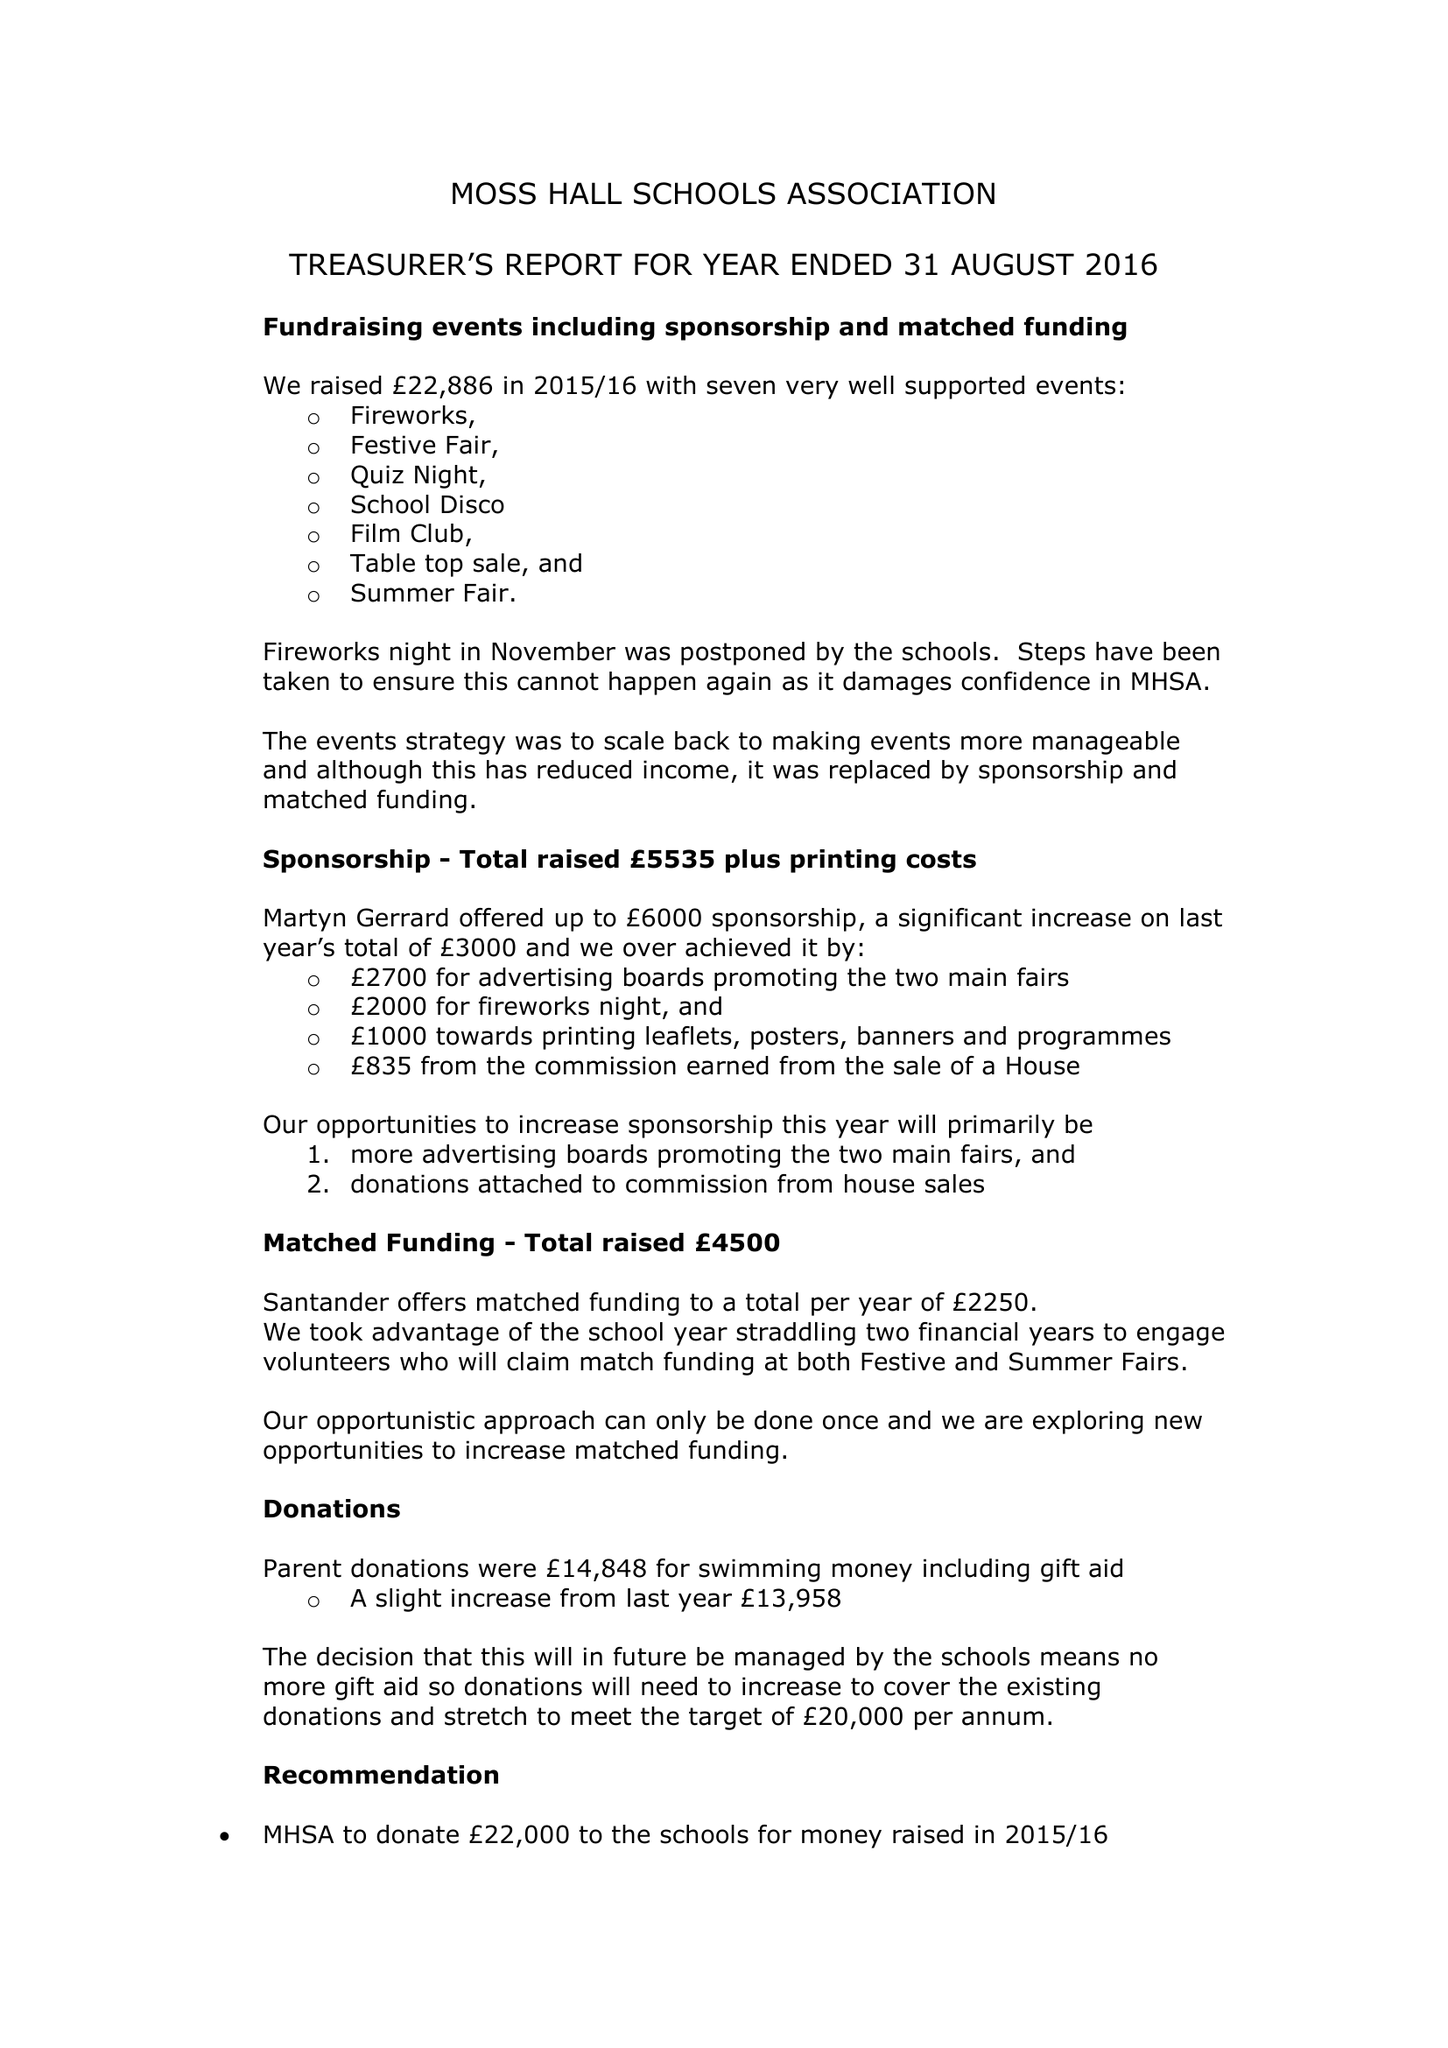What is the value for the address__street_line?
Answer the question using a single word or phrase. None 